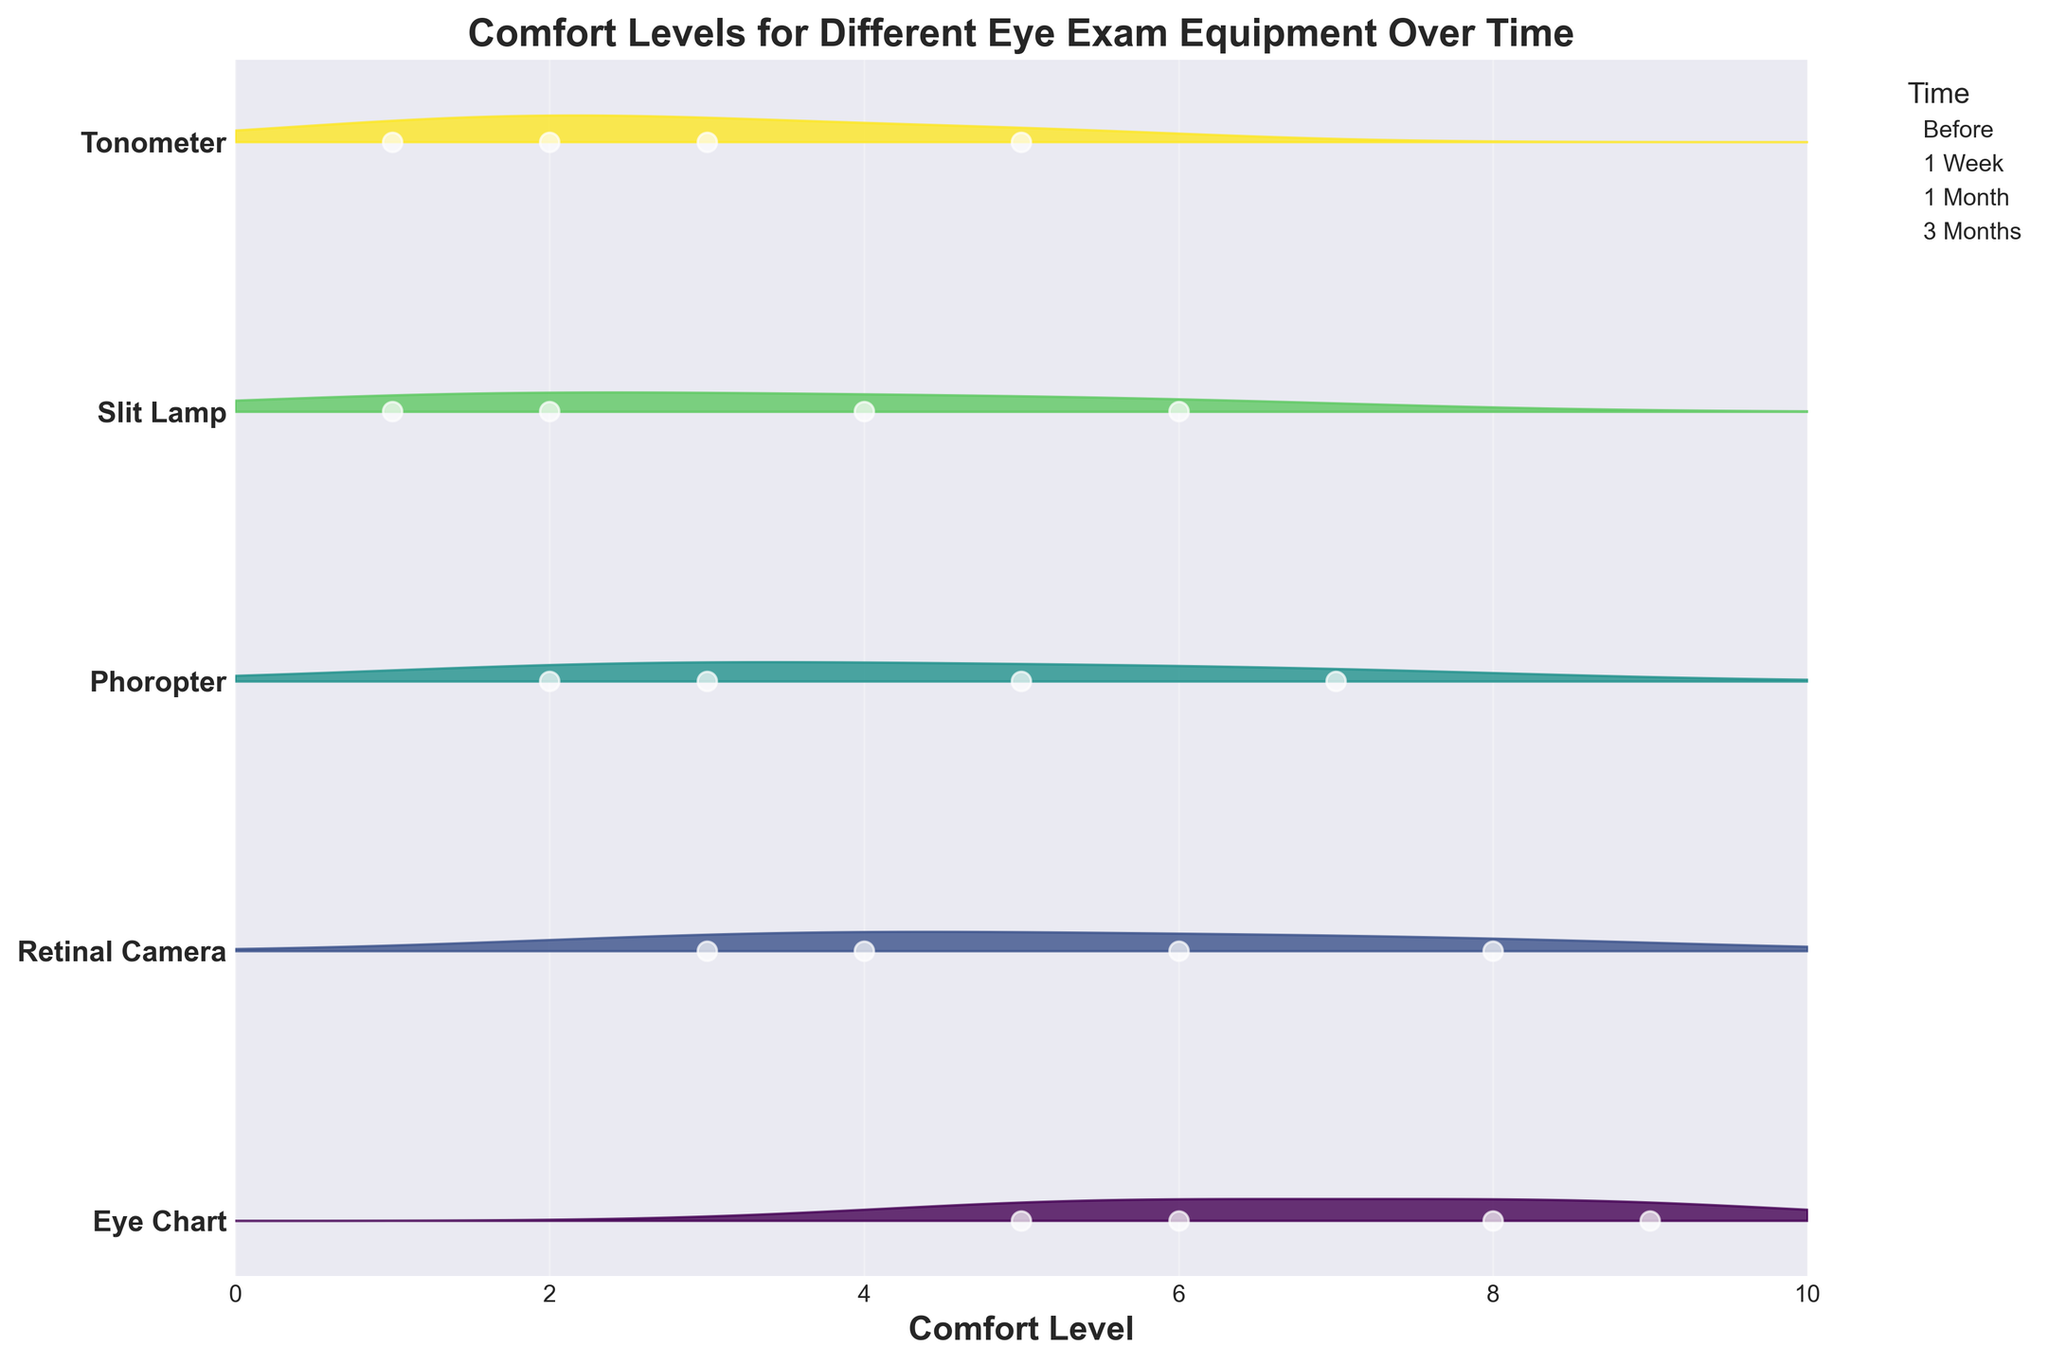What's the title of the figure? The title of the figure is usually placed at the top and describes what the data is about. In this case, it says "Comfort Levels for Different Eye Exam Equipment Over Time."
Answer: Comfort Levels for Different Eye Exam Equipment Over Time Which piece of equipment was reported to have the most comfortable starting level before usage? By looking at the data points in the "Before" category, the Eye Chart has the highest comfort level.
Answer: Eye Chart What is the trend of comfort levels for the Tonometer over time? The plot shows that the comfort levels for the Tonometer start low and gradually increase over time. Specifically, they move from 1 (Before) to 2 (1 Week), then to 3 (1 Month), and finally to 5 (3 Months).
Answer: Increasing Which equipment shows the largest increase in comfort level from before to 3 months? By comparing the comfort levels for each piece of equipment, we see that the Retinal Camera increases from 3 (Before) to 8 (3 Months), an increase of 5 units, which is the largest.
Answer: Retinal Camera How does the comfort level for the Phoropter at 1 Month compare to the Slit Lamp at the same time point? By examining the comfort levels at the 1 Month mark, the Phoropter is at level 5 while the Slit Lamp is at level 4. This shows that the Phoropter has a higher comfort level.
Answer: Phoropter What color represents the Eye Chart in the plot? Each piece of equipment is represented by different colors in the Ridgeline plot. The Eye Chart is represented by a specific color (the initial or top one in the color map).
Answer: (Refer to color in the plot, e.g., green/purple depending on the color map) What's the overall comfort trend for the Slit Lamp over the measured periods? The comfort levels for the Slit Lamp gradually increase over time from 1 (Before) to 6 (3 months). This shows a general upward trend.
Answer: Increasing Which equipment starts with the lowest comfort level, and what is its value? By looking at the initial comfort levels for each piece of equipment, both the Slit Lamp and Tonometer start at a comfort level of 1.
Answer: Slit Lamp and Tonometer Is there any equipment whose comfort level does not reach 6 or more by the 3-month mark? By examining the final comfort levels at the 3-month time point, all pieces of equipment except the Tonometer and Slit Lamp reach at least a comfort level of 6.
Answer: Tonometer Which piece of equipment has the most significant density increase on the plot? The density increase can be visually assessed by looking at the fill between the curves; the Eye Chart shows the most substantial fill, indicating the most significant density increase.
Answer: Eye Chart 